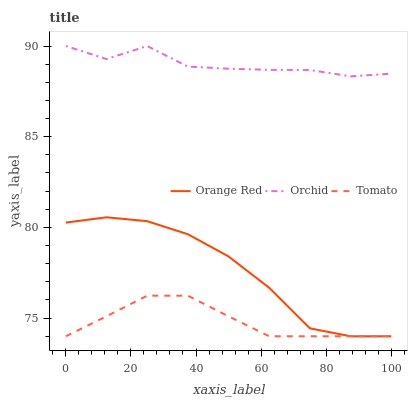Does Tomato have the minimum area under the curve?
Answer yes or no. Yes. Does Orchid have the maximum area under the curve?
Answer yes or no. Yes. Does Orange Red have the minimum area under the curve?
Answer yes or no. No. Does Orange Red have the maximum area under the curve?
Answer yes or no. No. Is Tomato the smoothest?
Answer yes or no. Yes. Is Orchid the roughest?
Answer yes or no. Yes. Is Orange Red the smoothest?
Answer yes or no. No. Is Orange Red the roughest?
Answer yes or no. No. Does Tomato have the lowest value?
Answer yes or no. Yes. Does Orchid have the lowest value?
Answer yes or no. No. Does Orchid have the highest value?
Answer yes or no. Yes. Does Orange Red have the highest value?
Answer yes or no. No. Is Tomato less than Orchid?
Answer yes or no. Yes. Is Orchid greater than Tomato?
Answer yes or no. Yes. Does Tomato intersect Orange Red?
Answer yes or no. Yes. Is Tomato less than Orange Red?
Answer yes or no. No. Is Tomato greater than Orange Red?
Answer yes or no. No. Does Tomato intersect Orchid?
Answer yes or no. No. 